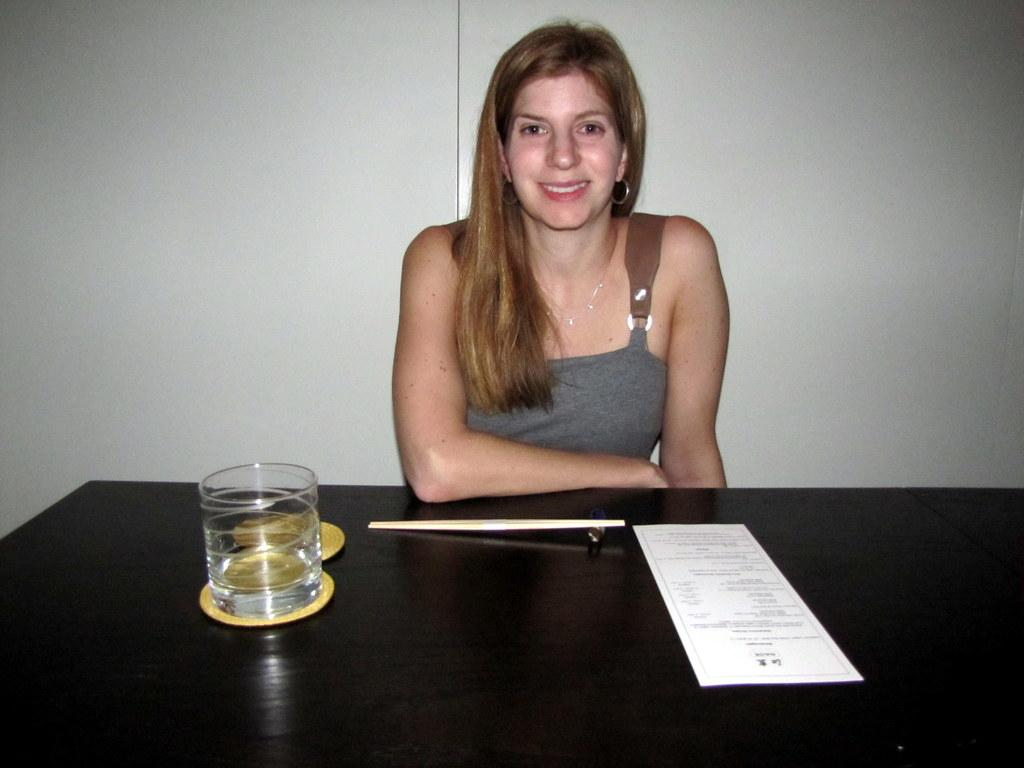What is the woman doing in the image? The woman is sitting at a table in the image. What can be seen on the table with the woman? There is a glass of water, a pair of chopsticks, and a piece of paper on the table. What might the woman be using to eat or pick up food? The woman might be using the chopsticks on the table to eat or pick up food. What type of crown is the toad wearing in the image? There is no toad or crown present in the image. 